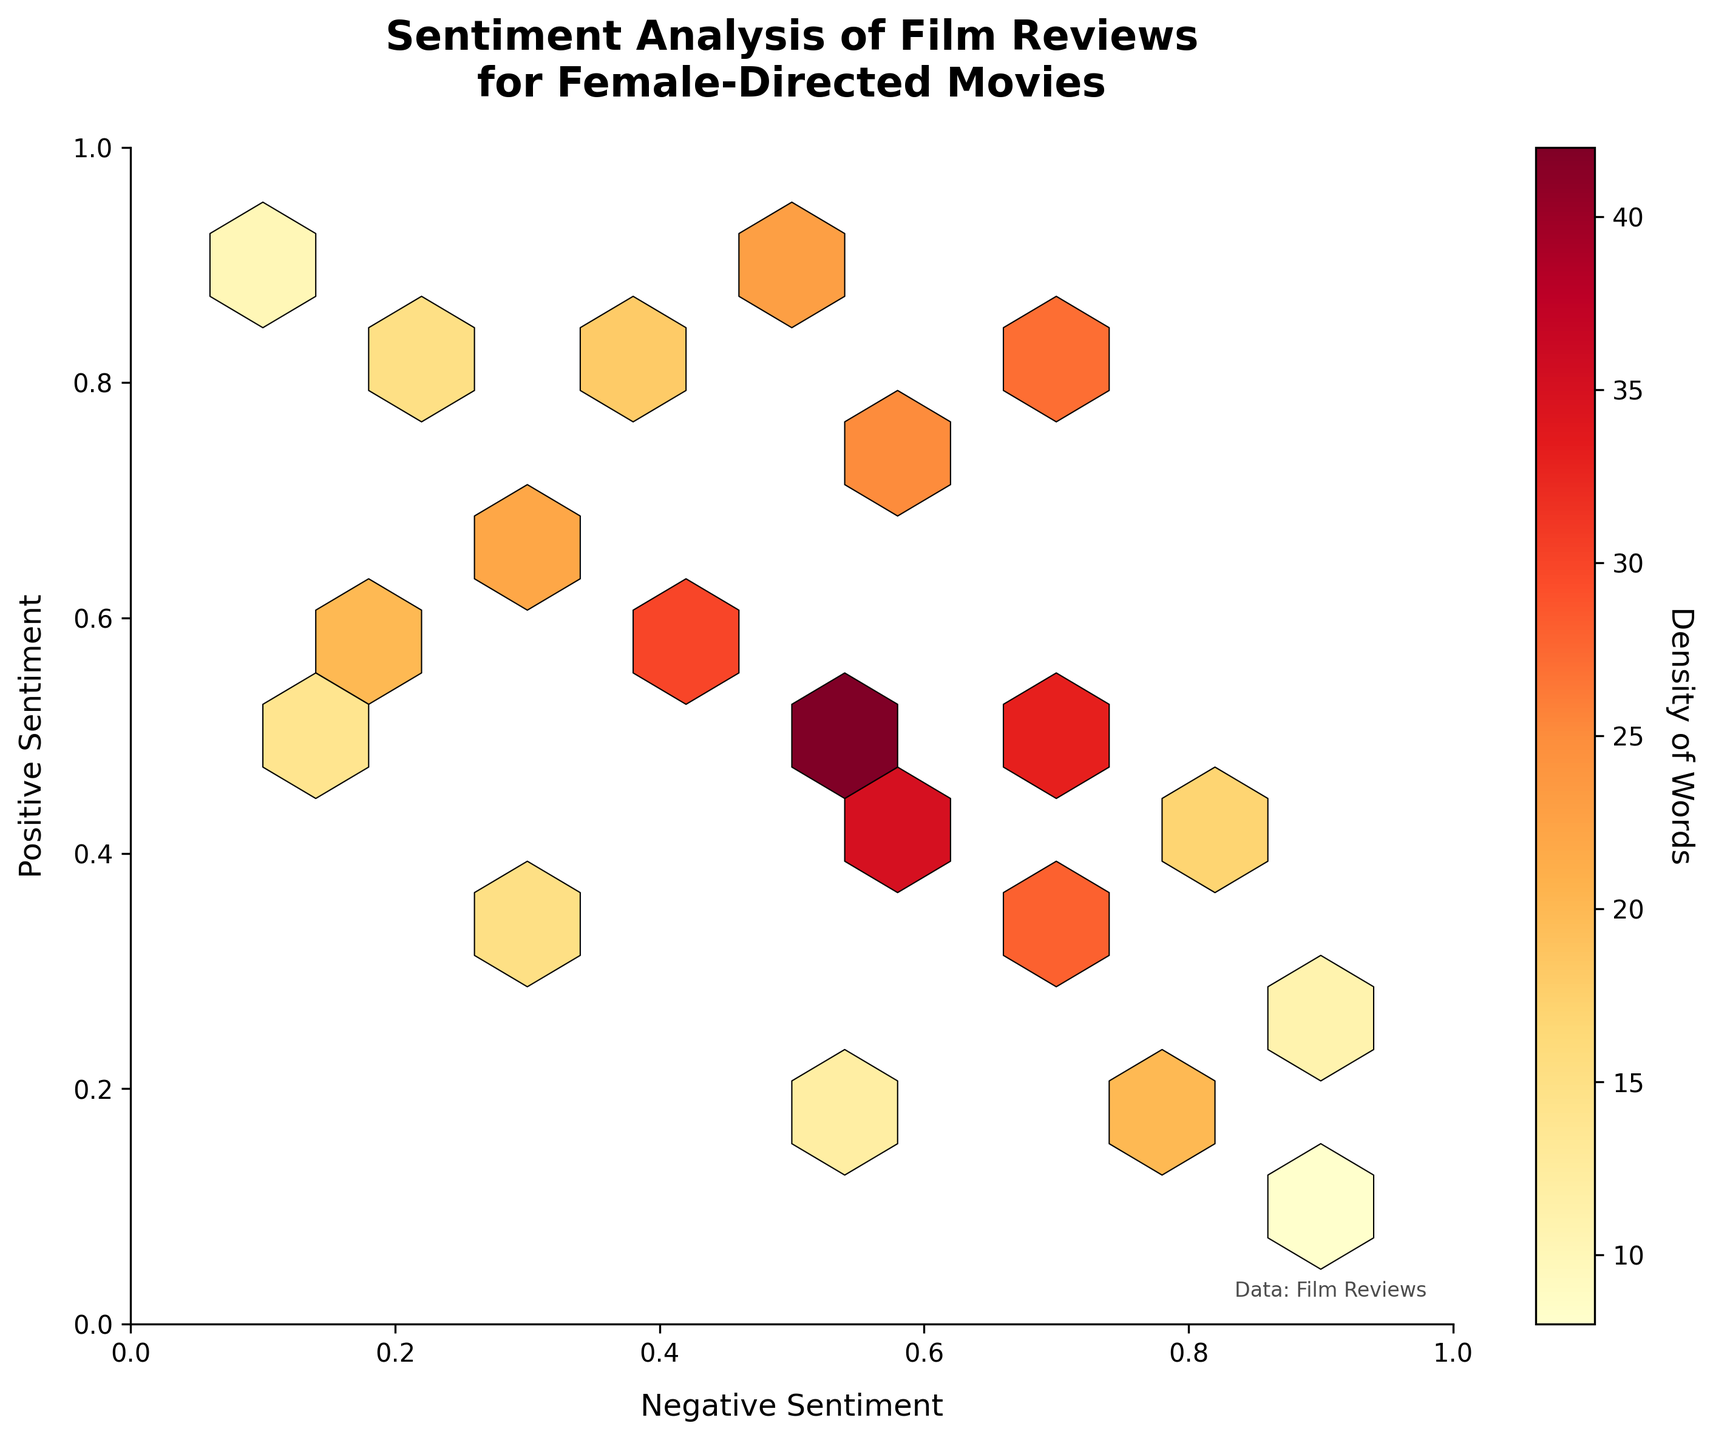what is the title of the chart? The title of the chart is displayed at the top. It reads "Sentiment Analysis of Film Reviews for Female-Directed Movies."
Answer: Sentiment Analysis of Film Reviews for Female-Directed Movies what do the axes represent? The x-axis represents "Negative Sentiment," and the y-axis represents "Positive Sentiment." These labels are indicated below and to the side of their respective axes.
Answer: Negative Sentiment (x), Positive Sentiment (y) which region has the highest density of words? The intensity of color in the hexbin plot indicates density. The region around (0.5, 0.5) has the highest density, as it's the area with the most concentrated darker color.
Answer: around (0.5, 0.5) where are the reviews with the most words located in terms of sentiment? The densest hexagons correlate with the highest density of words, which are around (0.5, 0.5). This suggests reviews with balanced sentiments contain the most words.
Answer: around (0.5, 0.5) what is the color associated with the highest density? The color bar to the right of the plot indicates density. The darkest color on the scale corresponds to the highest density, which is a deep red.
Answer: deep red how many word densities are there with a negative sentiment of 0.4 and a positive sentiment of 0.6 or higher? There are multiple hexagons in the region with a negative sentiment of 0.4. By observation, the hexagons at (0.4, 0.6) and (0.4, 0.8) would satisfy this condition.
Answer: 2 which hexagons have more words: those at (0.6, 0.4) or those at (0.4, 0.6)? The color intensity and the data suggest that the hexagon at (0.4, 0.6) has more words with a value of 30 compared to 35 at (0.6, 0.4).
Answer: (0.6, 0.4) for a 0.3 negative sentiment score, which positive sentiment score has higher word density: 0.7 or 0.3? For a 0.3 negative sentiment, compare the hexagons at (0.3, 0.7) and (0.3, 0.3). The data shows that (0.3, 0.7) has a density of 22 and (0.3, 0.3) has a density of 15. Therefore, 0.7 has a higher word density.
Answer: 0.7 what does the color bar represent? The color bar on the right represents "Density of Words." This shows how the density of words used in reviews varies across different sentiment combinations.
Answer: Density of Words which sentiment combination has the lowest word density? The hexagon with the sparsest color intensity indicates the lowest density. This appears around (0.9, 0.1), which correlates with a low word density.
Answer: around (0.9, 0.1) is there a trend in word density as the positive sentiment increases while keeping the negative sentiment constant at 0.7? By looking vertically along the 0.7 negative sentiment line, the word density generally decreases as positive sentiment increases, moving from darker to lighter colors.
Answer: decreases 